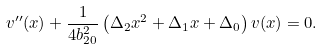<formula> <loc_0><loc_0><loc_500><loc_500>v ^ { \prime \prime } ( x ) + \frac { 1 } { 4 b _ { 2 0 } ^ { 2 } } \left ( \Delta _ { 2 } x ^ { 2 } + \Delta _ { 1 } x + \Delta _ { 0 } \right ) v ( x ) = 0 .</formula> 